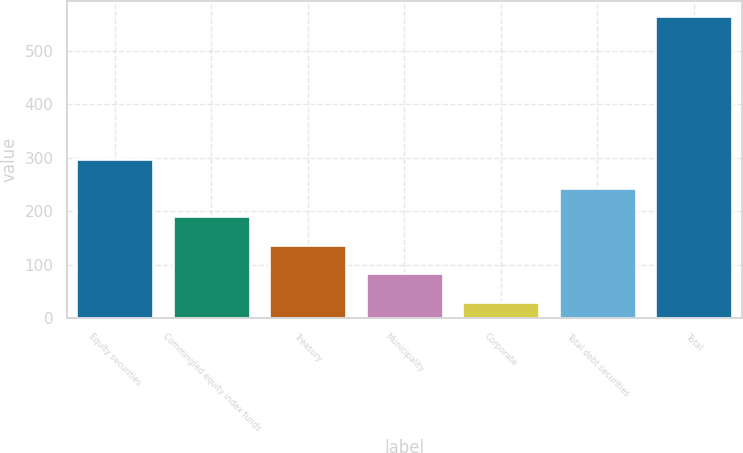Convert chart to OTSL. <chart><loc_0><loc_0><loc_500><loc_500><bar_chart><fcel>Equity securities<fcel>Commingled equity index funds<fcel>Treasury<fcel>Municipality<fcel>Corporate<fcel>Total debt securities<fcel>Total<nl><fcel>298<fcel>191.2<fcel>137.8<fcel>84.4<fcel>31<fcel>244.6<fcel>565<nl></chart> 